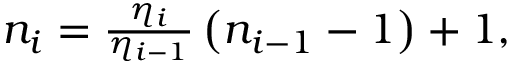Convert formula to latex. <formula><loc_0><loc_0><loc_500><loc_500>\begin{array} { r } { n _ { i } = \frac { \eta _ { i } } { \eta _ { i - 1 } } \left ( n _ { i - 1 } - 1 \right ) + 1 , } \end{array}</formula> 